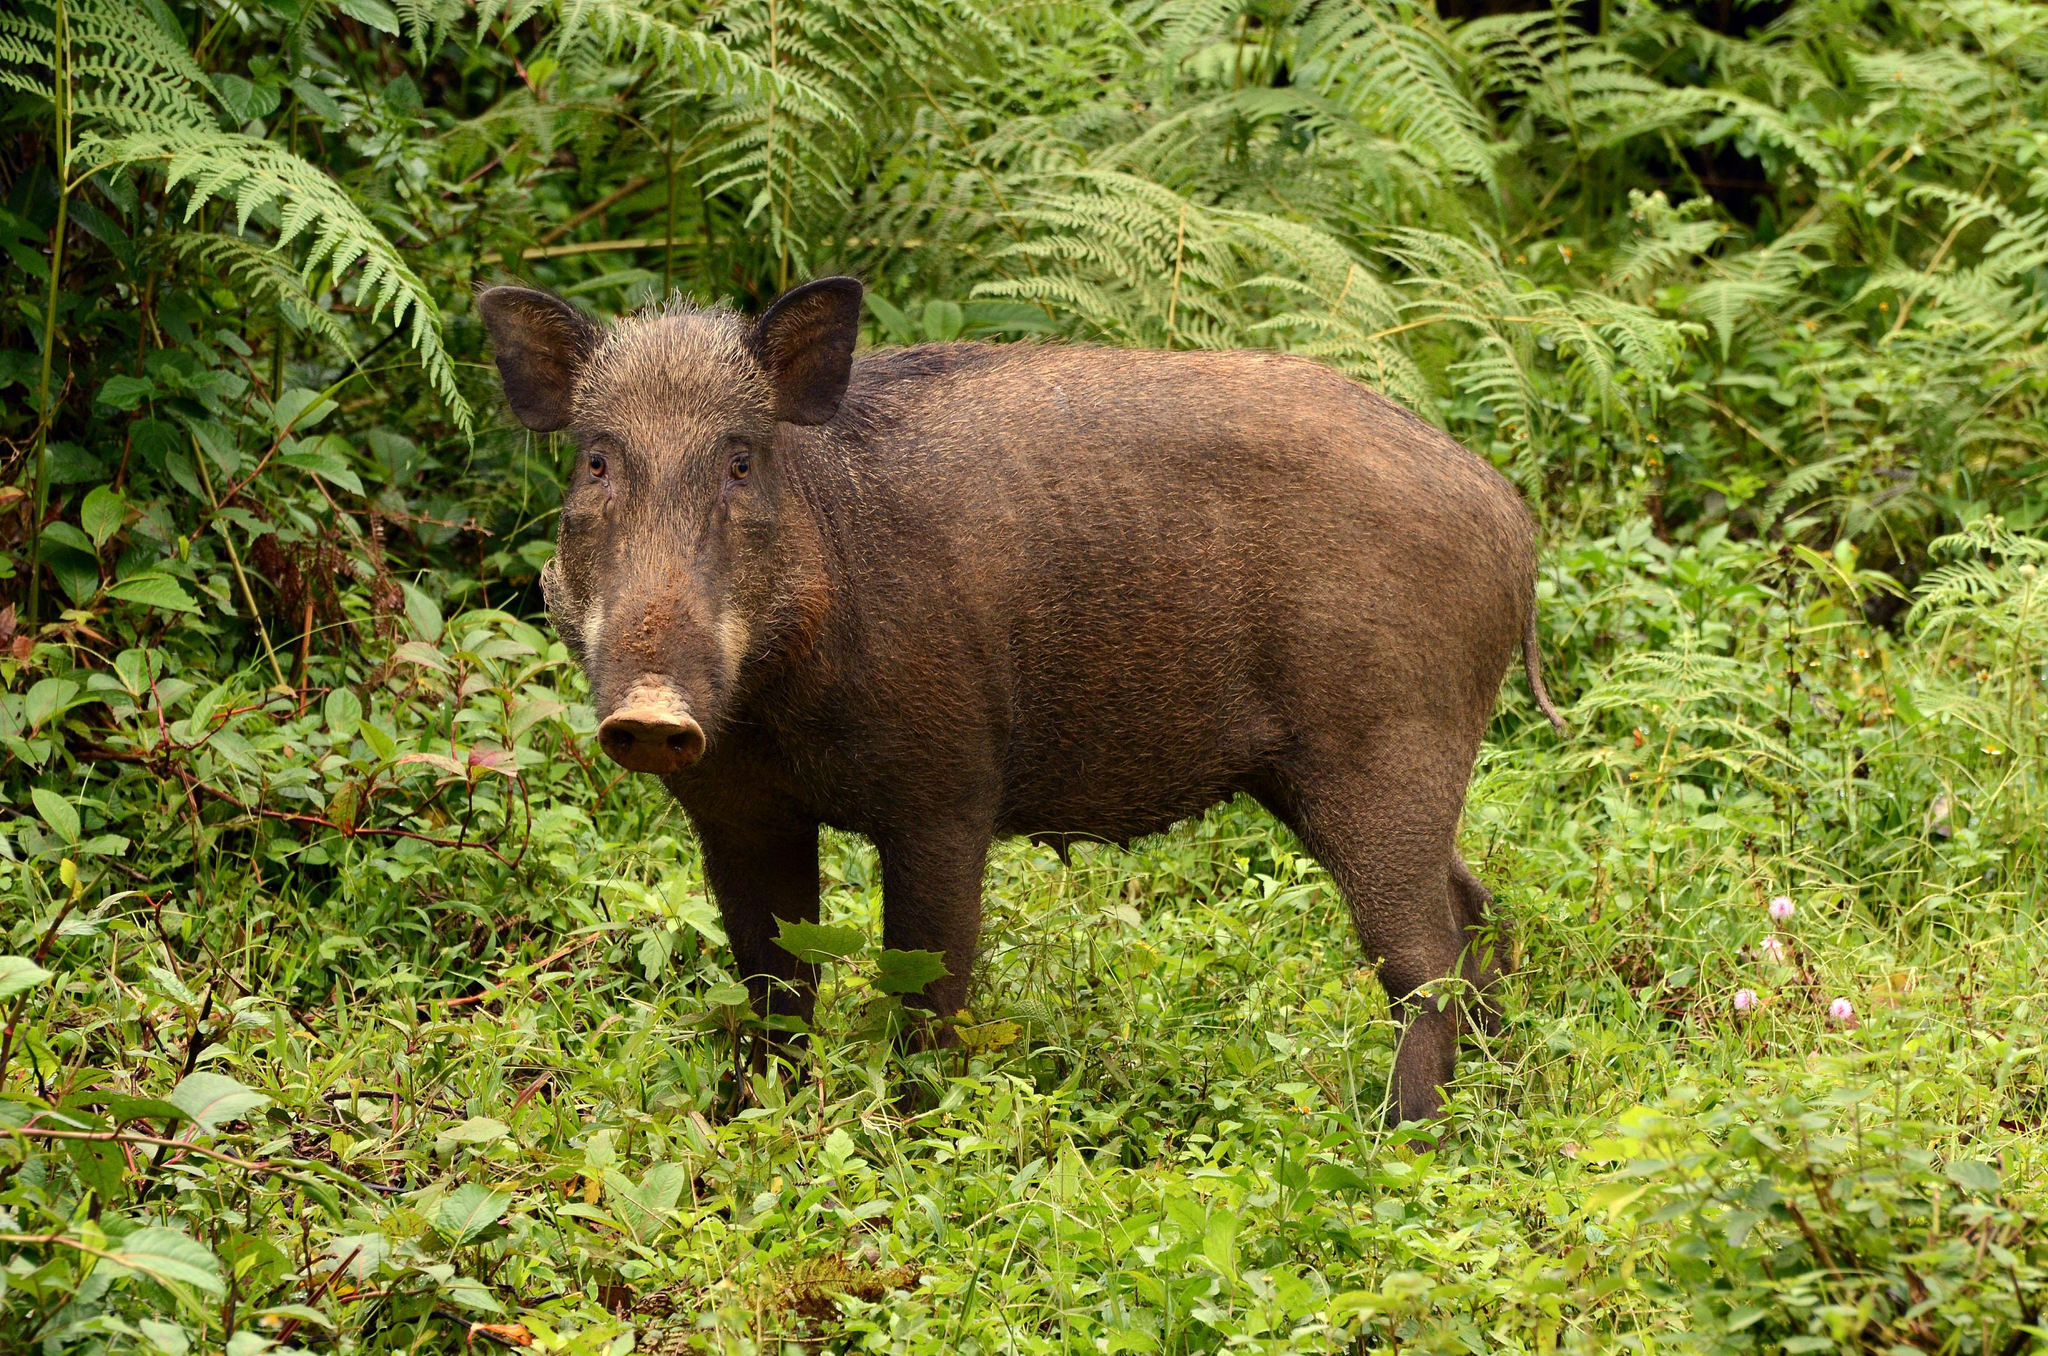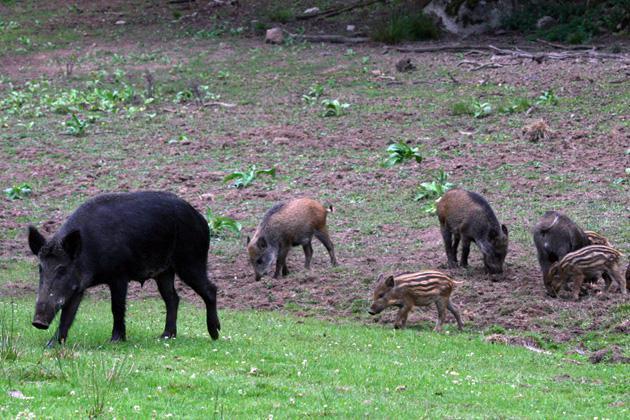The first image is the image on the left, the second image is the image on the right. Assess this claim about the two images: "There are at least 9 wild boars in each set of images.". Correct or not? Answer yes or no. No. The first image is the image on the left, the second image is the image on the right. Analyze the images presented: Is the assertion "One image prominently features a single mature pig standing in profile, and the other image includes at least one piglet with distinctive stripes." valid? Answer yes or no. Yes. 